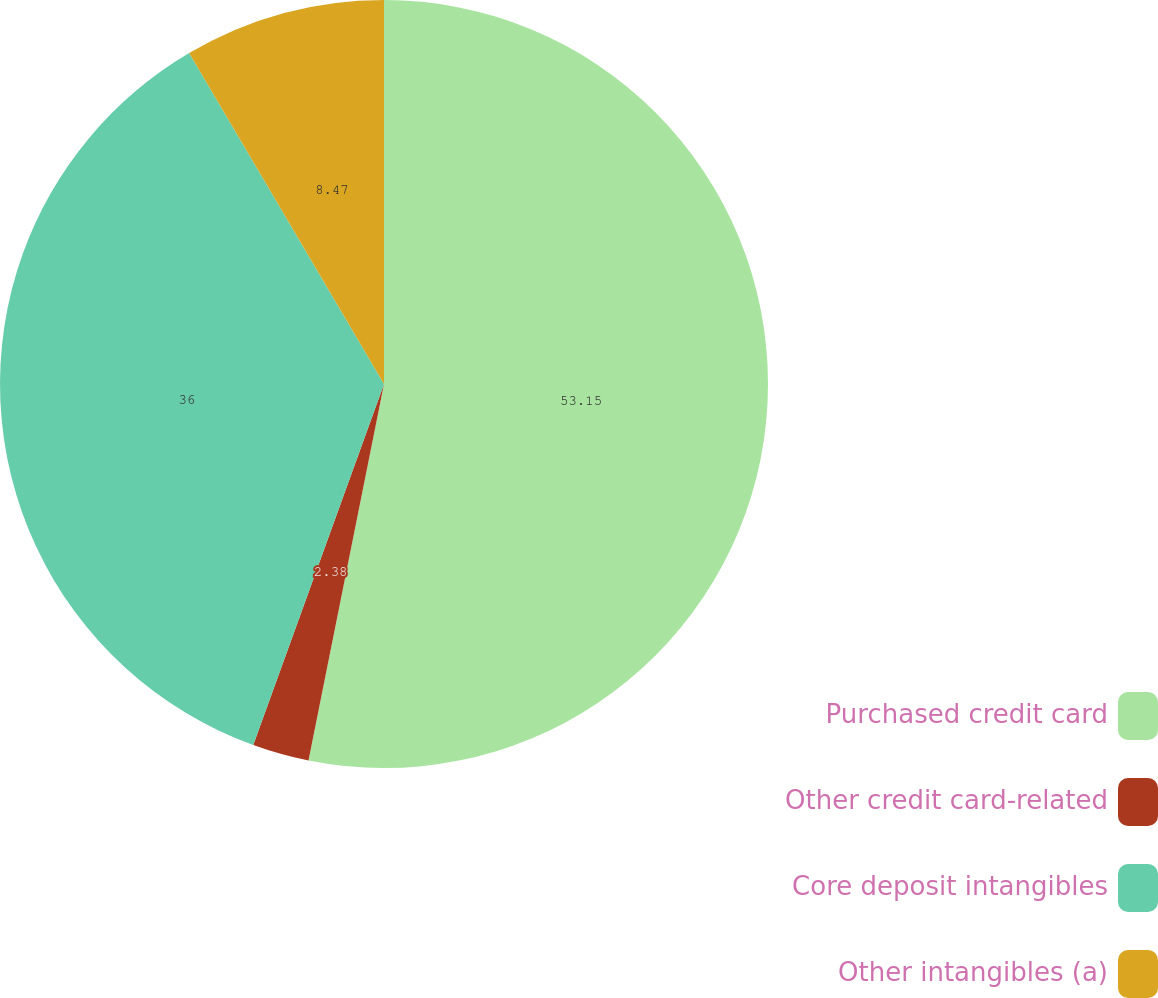<chart> <loc_0><loc_0><loc_500><loc_500><pie_chart><fcel>Purchased credit card<fcel>Other credit card-related<fcel>Core deposit intangibles<fcel>Other intangibles (a)<nl><fcel>53.15%<fcel>2.38%<fcel>36.0%<fcel>8.47%<nl></chart> 